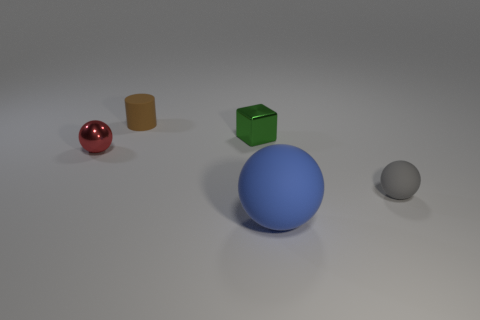There is a small matte object that is on the left side of the small shiny object behind the small shiny object that is to the left of the tiny brown object; what is its shape?
Your answer should be very brief. Cylinder. Are there any small balls made of the same material as the tiny cylinder?
Offer a terse response. Yes. Are there fewer small red metal balls that are behind the big blue ball than rubber balls?
Offer a terse response. Yes. How many things are either tiny blue metallic balls or spheres that are on the left side of the large blue rubber sphere?
Give a very brief answer. 1. There is a tiny sphere that is the same material as the big object; what is its color?
Keep it short and to the point. Gray. How many objects are either small brown things or blue metallic cylinders?
Your answer should be compact. 1. What is the color of the metal block that is the same size as the brown rubber thing?
Keep it short and to the point. Green. How many things are either balls that are to the left of the big sphere or yellow metallic objects?
Provide a short and direct response. 1. What number of other things are the same size as the brown matte thing?
Your answer should be very brief. 3. What size is the ball in front of the gray matte sphere?
Your answer should be very brief. Large. 